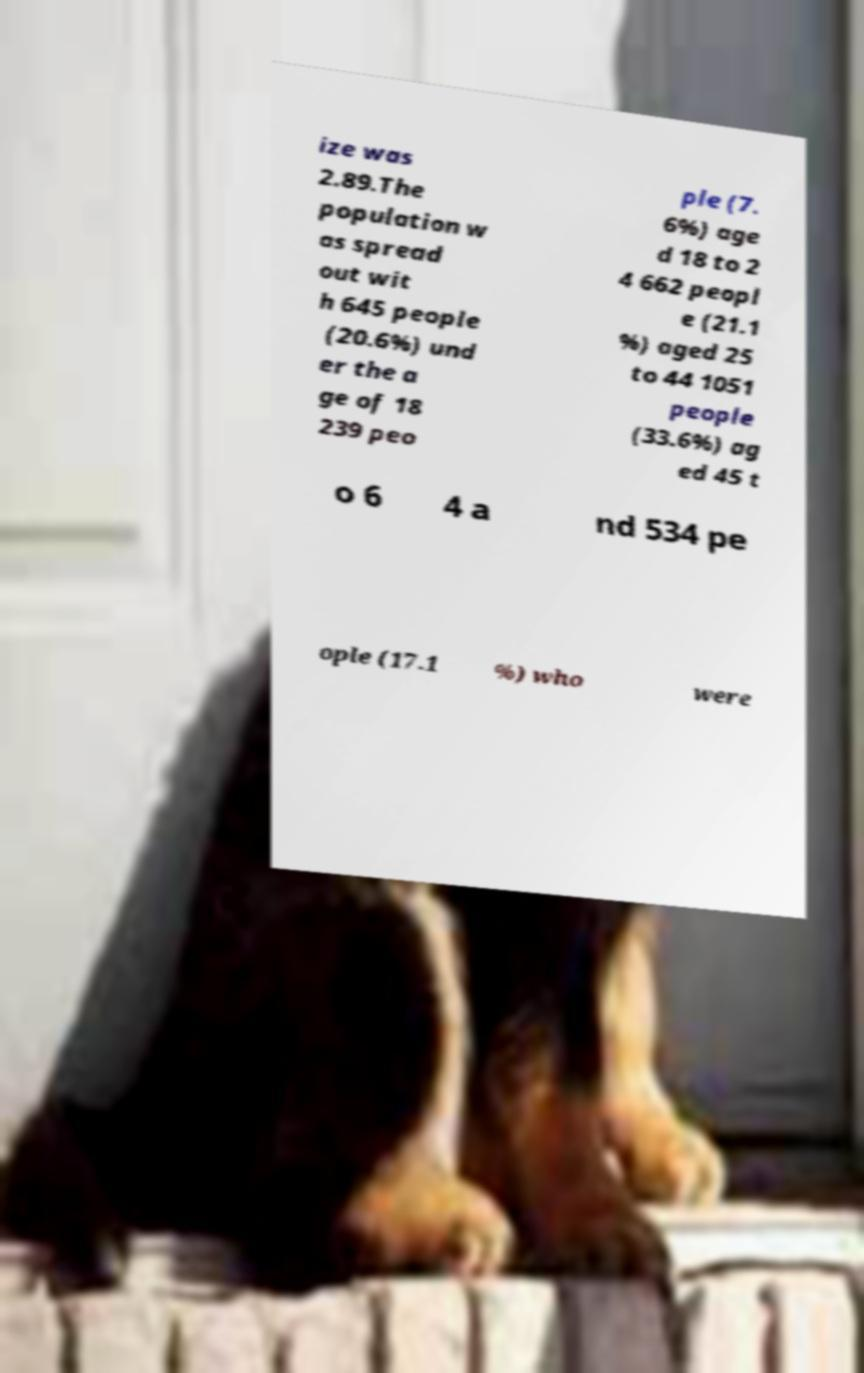Please read and relay the text visible in this image. What does it say? ize was 2.89.The population w as spread out wit h 645 people (20.6%) und er the a ge of 18 239 peo ple (7. 6%) age d 18 to 2 4 662 peopl e (21.1 %) aged 25 to 44 1051 people (33.6%) ag ed 45 t o 6 4 a nd 534 pe ople (17.1 %) who were 